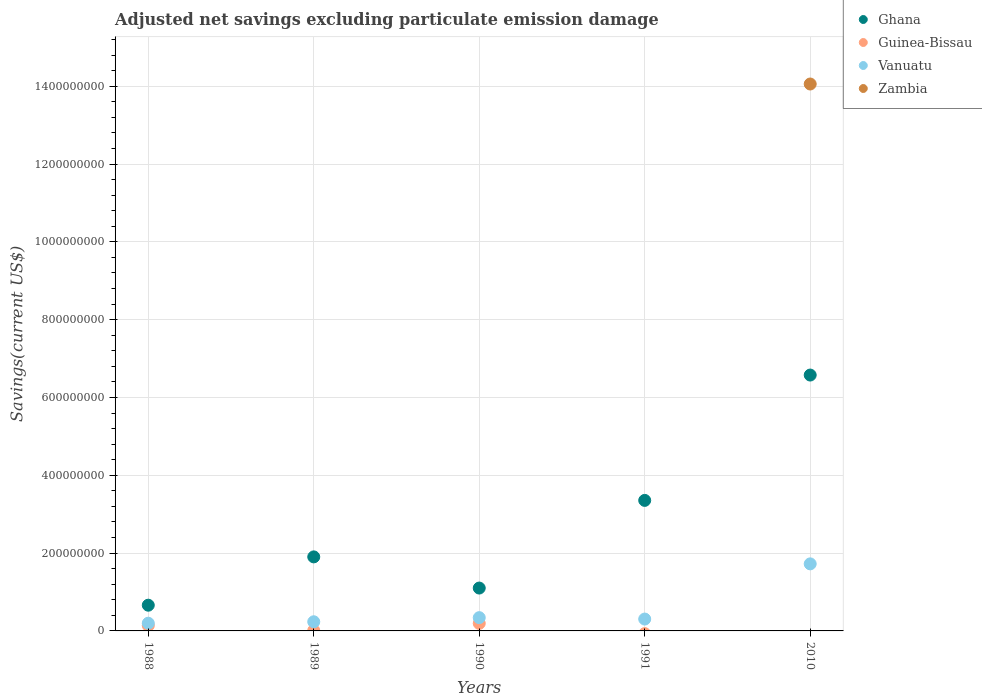How many different coloured dotlines are there?
Keep it short and to the point. 4. What is the adjusted net savings in Zambia in 1988?
Offer a very short reply. 0. Across all years, what is the maximum adjusted net savings in Zambia?
Your response must be concise. 1.41e+09. Across all years, what is the minimum adjusted net savings in Ghana?
Offer a very short reply. 6.61e+07. What is the total adjusted net savings in Zambia in the graph?
Your answer should be very brief. 1.41e+09. What is the difference between the adjusted net savings in Ghana in 1989 and that in 2010?
Provide a succinct answer. -4.67e+08. What is the difference between the adjusted net savings in Guinea-Bissau in 1988 and the adjusted net savings in Vanuatu in 2010?
Offer a very short reply. -1.58e+08. What is the average adjusted net savings in Zambia per year?
Make the answer very short. 2.81e+08. In the year 2010, what is the difference between the adjusted net savings in Ghana and adjusted net savings in Zambia?
Keep it short and to the point. -7.48e+08. In how many years, is the adjusted net savings in Zambia greater than 160000000 US$?
Offer a very short reply. 1. What is the ratio of the adjusted net savings in Vanuatu in 1988 to that in 1990?
Your response must be concise. 0.58. Is the adjusted net savings in Vanuatu in 1988 less than that in 1989?
Your answer should be compact. Yes. What is the difference between the highest and the second highest adjusted net savings in Vanuatu?
Your answer should be compact. 1.38e+08. What is the difference between the highest and the lowest adjusted net savings in Zambia?
Ensure brevity in your answer.  1.41e+09. Is the sum of the adjusted net savings in Ghana in 1989 and 1990 greater than the maximum adjusted net savings in Guinea-Bissau across all years?
Give a very brief answer. Yes. Does the adjusted net savings in Vanuatu monotonically increase over the years?
Your answer should be compact. No. Is the adjusted net savings in Guinea-Bissau strictly less than the adjusted net savings in Vanuatu over the years?
Your answer should be compact. Yes. Does the graph contain any zero values?
Your response must be concise. Yes. Where does the legend appear in the graph?
Make the answer very short. Top right. How are the legend labels stacked?
Give a very brief answer. Vertical. What is the title of the graph?
Keep it short and to the point. Adjusted net savings excluding particulate emission damage. Does "St. Martin (French part)" appear as one of the legend labels in the graph?
Give a very brief answer. No. What is the label or title of the X-axis?
Provide a short and direct response. Years. What is the label or title of the Y-axis?
Keep it short and to the point. Savings(current US$). What is the Savings(current US$) of Ghana in 1988?
Your answer should be compact. 6.61e+07. What is the Savings(current US$) of Guinea-Bissau in 1988?
Offer a very short reply. 1.39e+07. What is the Savings(current US$) in Vanuatu in 1988?
Your answer should be very brief. 1.98e+07. What is the Savings(current US$) of Zambia in 1988?
Provide a succinct answer. 0. What is the Savings(current US$) of Ghana in 1989?
Offer a very short reply. 1.90e+08. What is the Savings(current US$) in Guinea-Bissau in 1989?
Your answer should be compact. 1.12e+06. What is the Savings(current US$) in Vanuatu in 1989?
Provide a short and direct response. 2.35e+07. What is the Savings(current US$) in Ghana in 1990?
Ensure brevity in your answer.  1.10e+08. What is the Savings(current US$) of Guinea-Bissau in 1990?
Provide a succinct answer. 1.94e+07. What is the Savings(current US$) of Vanuatu in 1990?
Keep it short and to the point. 3.41e+07. What is the Savings(current US$) in Ghana in 1991?
Your answer should be very brief. 3.35e+08. What is the Savings(current US$) in Vanuatu in 1991?
Your answer should be compact. 3.05e+07. What is the Savings(current US$) of Ghana in 2010?
Your answer should be compact. 6.58e+08. What is the Savings(current US$) in Guinea-Bissau in 2010?
Offer a terse response. 0. What is the Savings(current US$) of Vanuatu in 2010?
Give a very brief answer. 1.72e+08. What is the Savings(current US$) of Zambia in 2010?
Provide a succinct answer. 1.41e+09. Across all years, what is the maximum Savings(current US$) in Ghana?
Your answer should be very brief. 6.58e+08. Across all years, what is the maximum Savings(current US$) in Guinea-Bissau?
Offer a very short reply. 1.94e+07. Across all years, what is the maximum Savings(current US$) of Vanuatu?
Ensure brevity in your answer.  1.72e+08. Across all years, what is the maximum Savings(current US$) of Zambia?
Your answer should be compact. 1.41e+09. Across all years, what is the minimum Savings(current US$) of Ghana?
Keep it short and to the point. 6.61e+07. Across all years, what is the minimum Savings(current US$) of Vanuatu?
Provide a succinct answer. 1.98e+07. Across all years, what is the minimum Savings(current US$) of Zambia?
Make the answer very short. 0. What is the total Savings(current US$) of Ghana in the graph?
Make the answer very short. 1.36e+09. What is the total Savings(current US$) in Guinea-Bissau in the graph?
Give a very brief answer. 3.44e+07. What is the total Savings(current US$) of Vanuatu in the graph?
Provide a succinct answer. 2.80e+08. What is the total Savings(current US$) in Zambia in the graph?
Your answer should be very brief. 1.41e+09. What is the difference between the Savings(current US$) of Ghana in 1988 and that in 1989?
Give a very brief answer. -1.24e+08. What is the difference between the Savings(current US$) of Guinea-Bissau in 1988 and that in 1989?
Make the answer very short. 1.28e+07. What is the difference between the Savings(current US$) of Vanuatu in 1988 and that in 1989?
Keep it short and to the point. -3.73e+06. What is the difference between the Savings(current US$) of Ghana in 1988 and that in 1990?
Keep it short and to the point. -4.41e+07. What is the difference between the Savings(current US$) in Guinea-Bissau in 1988 and that in 1990?
Provide a short and direct response. -5.49e+06. What is the difference between the Savings(current US$) of Vanuatu in 1988 and that in 1990?
Offer a terse response. -1.43e+07. What is the difference between the Savings(current US$) of Ghana in 1988 and that in 1991?
Provide a short and direct response. -2.69e+08. What is the difference between the Savings(current US$) of Vanuatu in 1988 and that in 1991?
Your response must be concise. -1.07e+07. What is the difference between the Savings(current US$) of Ghana in 1988 and that in 2010?
Your answer should be very brief. -5.91e+08. What is the difference between the Savings(current US$) of Vanuatu in 1988 and that in 2010?
Provide a short and direct response. -1.53e+08. What is the difference between the Savings(current US$) in Ghana in 1989 and that in 1990?
Ensure brevity in your answer.  8.01e+07. What is the difference between the Savings(current US$) in Guinea-Bissau in 1989 and that in 1990?
Ensure brevity in your answer.  -1.83e+07. What is the difference between the Savings(current US$) in Vanuatu in 1989 and that in 1990?
Keep it short and to the point. -1.06e+07. What is the difference between the Savings(current US$) of Ghana in 1989 and that in 1991?
Your answer should be compact. -1.45e+08. What is the difference between the Savings(current US$) in Vanuatu in 1989 and that in 1991?
Provide a short and direct response. -6.97e+06. What is the difference between the Savings(current US$) in Ghana in 1989 and that in 2010?
Your response must be concise. -4.67e+08. What is the difference between the Savings(current US$) in Vanuatu in 1989 and that in 2010?
Your answer should be very brief. -1.49e+08. What is the difference between the Savings(current US$) in Ghana in 1990 and that in 1991?
Your response must be concise. -2.25e+08. What is the difference between the Savings(current US$) in Vanuatu in 1990 and that in 1991?
Offer a terse response. 3.59e+06. What is the difference between the Savings(current US$) in Ghana in 1990 and that in 2010?
Give a very brief answer. -5.47e+08. What is the difference between the Savings(current US$) in Vanuatu in 1990 and that in 2010?
Offer a very short reply. -1.38e+08. What is the difference between the Savings(current US$) in Ghana in 1991 and that in 2010?
Your answer should be compact. -3.22e+08. What is the difference between the Savings(current US$) of Vanuatu in 1991 and that in 2010?
Provide a short and direct response. -1.42e+08. What is the difference between the Savings(current US$) in Ghana in 1988 and the Savings(current US$) in Guinea-Bissau in 1989?
Your response must be concise. 6.50e+07. What is the difference between the Savings(current US$) in Ghana in 1988 and the Savings(current US$) in Vanuatu in 1989?
Provide a short and direct response. 4.26e+07. What is the difference between the Savings(current US$) in Guinea-Bissau in 1988 and the Savings(current US$) in Vanuatu in 1989?
Ensure brevity in your answer.  -9.65e+06. What is the difference between the Savings(current US$) in Ghana in 1988 and the Savings(current US$) in Guinea-Bissau in 1990?
Your answer should be compact. 4.67e+07. What is the difference between the Savings(current US$) of Ghana in 1988 and the Savings(current US$) of Vanuatu in 1990?
Give a very brief answer. 3.20e+07. What is the difference between the Savings(current US$) of Guinea-Bissau in 1988 and the Savings(current US$) of Vanuatu in 1990?
Keep it short and to the point. -2.02e+07. What is the difference between the Savings(current US$) of Ghana in 1988 and the Savings(current US$) of Vanuatu in 1991?
Keep it short and to the point. 3.56e+07. What is the difference between the Savings(current US$) of Guinea-Bissau in 1988 and the Savings(current US$) of Vanuatu in 1991?
Ensure brevity in your answer.  -1.66e+07. What is the difference between the Savings(current US$) in Ghana in 1988 and the Savings(current US$) in Vanuatu in 2010?
Keep it short and to the point. -1.06e+08. What is the difference between the Savings(current US$) in Ghana in 1988 and the Savings(current US$) in Zambia in 2010?
Give a very brief answer. -1.34e+09. What is the difference between the Savings(current US$) of Guinea-Bissau in 1988 and the Savings(current US$) of Vanuatu in 2010?
Ensure brevity in your answer.  -1.58e+08. What is the difference between the Savings(current US$) of Guinea-Bissau in 1988 and the Savings(current US$) of Zambia in 2010?
Make the answer very short. -1.39e+09. What is the difference between the Savings(current US$) in Vanuatu in 1988 and the Savings(current US$) in Zambia in 2010?
Your response must be concise. -1.39e+09. What is the difference between the Savings(current US$) in Ghana in 1989 and the Savings(current US$) in Guinea-Bissau in 1990?
Offer a terse response. 1.71e+08. What is the difference between the Savings(current US$) in Ghana in 1989 and the Savings(current US$) in Vanuatu in 1990?
Ensure brevity in your answer.  1.56e+08. What is the difference between the Savings(current US$) in Guinea-Bissau in 1989 and the Savings(current US$) in Vanuatu in 1990?
Your answer should be very brief. -3.30e+07. What is the difference between the Savings(current US$) of Ghana in 1989 and the Savings(current US$) of Vanuatu in 1991?
Keep it short and to the point. 1.60e+08. What is the difference between the Savings(current US$) in Guinea-Bissau in 1989 and the Savings(current US$) in Vanuatu in 1991?
Your answer should be compact. -2.94e+07. What is the difference between the Savings(current US$) in Ghana in 1989 and the Savings(current US$) in Vanuatu in 2010?
Ensure brevity in your answer.  1.79e+07. What is the difference between the Savings(current US$) of Ghana in 1989 and the Savings(current US$) of Zambia in 2010?
Keep it short and to the point. -1.22e+09. What is the difference between the Savings(current US$) in Guinea-Bissau in 1989 and the Savings(current US$) in Vanuatu in 2010?
Your answer should be very brief. -1.71e+08. What is the difference between the Savings(current US$) of Guinea-Bissau in 1989 and the Savings(current US$) of Zambia in 2010?
Your answer should be compact. -1.40e+09. What is the difference between the Savings(current US$) in Vanuatu in 1989 and the Savings(current US$) in Zambia in 2010?
Offer a very short reply. -1.38e+09. What is the difference between the Savings(current US$) in Ghana in 1990 and the Savings(current US$) in Vanuatu in 1991?
Your answer should be compact. 7.97e+07. What is the difference between the Savings(current US$) in Guinea-Bissau in 1990 and the Savings(current US$) in Vanuatu in 1991?
Your answer should be compact. -1.11e+07. What is the difference between the Savings(current US$) of Ghana in 1990 and the Savings(current US$) of Vanuatu in 2010?
Your answer should be very brief. -6.22e+07. What is the difference between the Savings(current US$) of Ghana in 1990 and the Savings(current US$) of Zambia in 2010?
Provide a short and direct response. -1.30e+09. What is the difference between the Savings(current US$) of Guinea-Bissau in 1990 and the Savings(current US$) of Vanuatu in 2010?
Make the answer very short. -1.53e+08. What is the difference between the Savings(current US$) in Guinea-Bissau in 1990 and the Savings(current US$) in Zambia in 2010?
Your answer should be very brief. -1.39e+09. What is the difference between the Savings(current US$) in Vanuatu in 1990 and the Savings(current US$) in Zambia in 2010?
Your response must be concise. -1.37e+09. What is the difference between the Savings(current US$) in Ghana in 1991 and the Savings(current US$) in Vanuatu in 2010?
Keep it short and to the point. 1.63e+08. What is the difference between the Savings(current US$) of Ghana in 1991 and the Savings(current US$) of Zambia in 2010?
Your answer should be compact. -1.07e+09. What is the difference between the Savings(current US$) of Vanuatu in 1991 and the Savings(current US$) of Zambia in 2010?
Give a very brief answer. -1.38e+09. What is the average Savings(current US$) in Ghana per year?
Ensure brevity in your answer.  2.72e+08. What is the average Savings(current US$) in Guinea-Bissau per year?
Offer a terse response. 6.87e+06. What is the average Savings(current US$) of Vanuatu per year?
Your answer should be very brief. 5.61e+07. What is the average Savings(current US$) of Zambia per year?
Your answer should be compact. 2.81e+08. In the year 1988, what is the difference between the Savings(current US$) in Ghana and Savings(current US$) in Guinea-Bissau?
Offer a terse response. 5.22e+07. In the year 1988, what is the difference between the Savings(current US$) in Ghana and Savings(current US$) in Vanuatu?
Make the answer very short. 4.63e+07. In the year 1988, what is the difference between the Savings(current US$) of Guinea-Bissau and Savings(current US$) of Vanuatu?
Give a very brief answer. -5.93e+06. In the year 1989, what is the difference between the Savings(current US$) of Ghana and Savings(current US$) of Guinea-Bissau?
Your answer should be very brief. 1.89e+08. In the year 1989, what is the difference between the Savings(current US$) of Ghana and Savings(current US$) of Vanuatu?
Your answer should be compact. 1.67e+08. In the year 1989, what is the difference between the Savings(current US$) of Guinea-Bissau and Savings(current US$) of Vanuatu?
Keep it short and to the point. -2.24e+07. In the year 1990, what is the difference between the Savings(current US$) of Ghana and Savings(current US$) of Guinea-Bissau?
Provide a short and direct response. 9.08e+07. In the year 1990, what is the difference between the Savings(current US$) of Ghana and Savings(current US$) of Vanuatu?
Offer a terse response. 7.61e+07. In the year 1990, what is the difference between the Savings(current US$) of Guinea-Bissau and Savings(current US$) of Vanuatu?
Your answer should be very brief. -1.47e+07. In the year 1991, what is the difference between the Savings(current US$) of Ghana and Savings(current US$) of Vanuatu?
Keep it short and to the point. 3.05e+08. In the year 2010, what is the difference between the Savings(current US$) of Ghana and Savings(current US$) of Vanuatu?
Your answer should be very brief. 4.85e+08. In the year 2010, what is the difference between the Savings(current US$) of Ghana and Savings(current US$) of Zambia?
Offer a very short reply. -7.48e+08. In the year 2010, what is the difference between the Savings(current US$) in Vanuatu and Savings(current US$) in Zambia?
Your answer should be compact. -1.23e+09. What is the ratio of the Savings(current US$) of Ghana in 1988 to that in 1989?
Give a very brief answer. 0.35. What is the ratio of the Savings(current US$) of Guinea-Bissau in 1988 to that in 1989?
Your response must be concise. 12.43. What is the ratio of the Savings(current US$) of Vanuatu in 1988 to that in 1989?
Provide a short and direct response. 0.84. What is the ratio of the Savings(current US$) of Ghana in 1988 to that in 1990?
Offer a very short reply. 0.6. What is the ratio of the Savings(current US$) of Guinea-Bissau in 1988 to that in 1990?
Keep it short and to the point. 0.72. What is the ratio of the Savings(current US$) in Vanuatu in 1988 to that in 1990?
Keep it short and to the point. 0.58. What is the ratio of the Savings(current US$) of Ghana in 1988 to that in 1991?
Your response must be concise. 0.2. What is the ratio of the Savings(current US$) in Vanuatu in 1988 to that in 1991?
Provide a succinct answer. 0.65. What is the ratio of the Savings(current US$) in Ghana in 1988 to that in 2010?
Ensure brevity in your answer.  0.1. What is the ratio of the Savings(current US$) in Vanuatu in 1988 to that in 2010?
Your answer should be compact. 0.11. What is the ratio of the Savings(current US$) in Ghana in 1989 to that in 1990?
Offer a terse response. 1.73. What is the ratio of the Savings(current US$) of Guinea-Bissau in 1989 to that in 1990?
Give a very brief answer. 0.06. What is the ratio of the Savings(current US$) in Vanuatu in 1989 to that in 1990?
Your answer should be very brief. 0.69. What is the ratio of the Savings(current US$) of Ghana in 1989 to that in 1991?
Give a very brief answer. 0.57. What is the ratio of the Savings(current US$) of Vanuatu in 1989 to that in 1991?
Your answer should be very brief. 0.77. What is the ratio of the Savings(current US$) in Ghana in 1989 to that in 2010?
Make the answer very short. 0.29. What is the ratio of the Savings(current US$) in Vanuatu in 1989 to that in 2010?
Keep it short and to the point. 0.14. What is the ratio of the Savings(current US$) in Ghana in 1990 to that in 1991?
Make the answer very short. 0.33. What is the ratio of the Savings(current US$) in Vanuatu in 1990 to that in 1991?
Offer a terse response. 1.12. What is the ratio of the Savings(current US$) of Ghana in 1990 to that in 2010?
Ensure brevity in your answer.  0.17. What is the ratio of the Savings(current US$) in Vanuatu in 1990 to that in 2010?
Your answer should be compact. 0.2. What is the ratio of the Savings(current US$) in Ghana in 1991 to that in 2010?
Ensure brevity in your answer.  0.51. What is the ratio of the Savings(current US$) in Vanuatu in 1991 to that in 2010?
Keep it short and to the point. 0.18. What is the difference between the highest and the second highest Savings(current US$) in Ghana?
Your answer should be very brief. 3.22e+08. What is the difference between the highest and the second highest Savings(current US$) in Guinea-Bissau?
Make the answer very short. 5.49e+06. What is the difference between the highest and the second highest Savings(current US$) in Vanuatu?
Make the answer very short. 1.38e+08. What is the difference between the highest and the lowest Savings(current US$) in Ghana?
Your answer should be compact. 5.91e+08. What is the difference between the highest and the lowest Savings(current US$) in Guinea-Bissau?
Keep it short and to the point. 1.94e+07. What is the difference between the highest and the lowest Savings(current US$) of Vanuatu?
Offer a terse response. 1.53e+08. What is the difference between the highest and the lowest Savings(current US$) of Zambia?
Ensure brevity in your answer.  1.41e+09. 